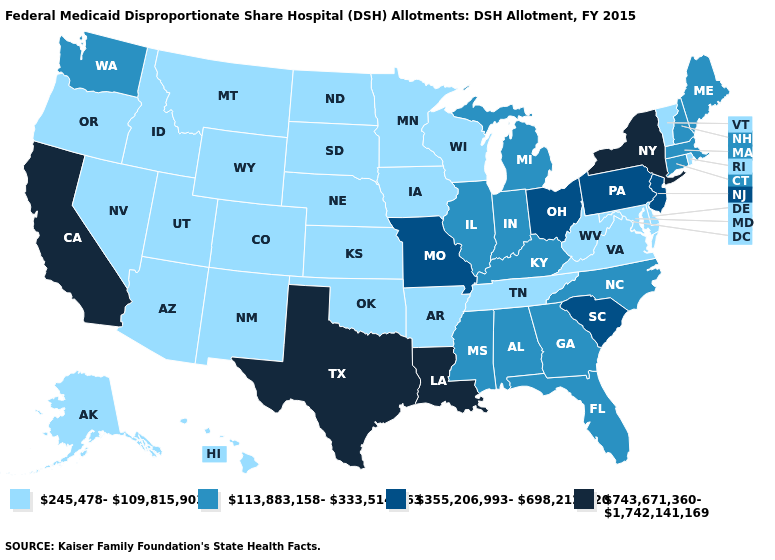What is the lowest value in the MidWest?
Be succinct. 245,478-109,815,903. Name the states that have a value in the range 743,671,360-1,742,141,169?
Answer briefly. California, Louisiana, New York, Texas. What is the highest value in states that border Maine?
Quick response, please. 113,883,158-333,514,963. Which states have the lowest value in the South?
Answer briefly. Arkansas, Delaware, Maryland, Oklahoma, Tennessee, Virginia, West Virginia. What is the highest value in the West ?
Be succinct. 743,671,360-1,742,141,169. Among the states that border Texas , which have the lowest value?
Be succinct. Arkansas, New Mexico, Oklahoma. Does Arkansas have the lowest value in the USA?
Give a very brief answer. Yes. Among the states that border Connecticut , does Rhode Island have the lowest value?
Keep it brief. Yes. Does the first symbol in the legend represent the smallest category?
Give a very brief answer. Yes. Name the states that have a value in the range 113,883,158-333,514,963?
Write a very short answer. Alabama, Connecticut, Florida, Georgia, Illinois, Indiana, Kentucky, Maine, Massachusetts, Michigan, Mississippi, New Hampshire, North Carolina, Washington. Which states have the lowest value in the MidWest?
Concise answer only. Iowa, Kansas, Minnesota, Nebraska, North Dakota, South Dakota, Wisconsin. What is the value of Oregon?
Keep it brief. 245,478-109,815,903. Among the states that border West Virginia , does Pennsylvania have the highest value?
Be succinct. Yes. What is the lowest value in the USA?
Keep it brief. 245,478-109,815,903. What is the value of California?
Write a very short answer. 743,671,360-1,742,141,169. 